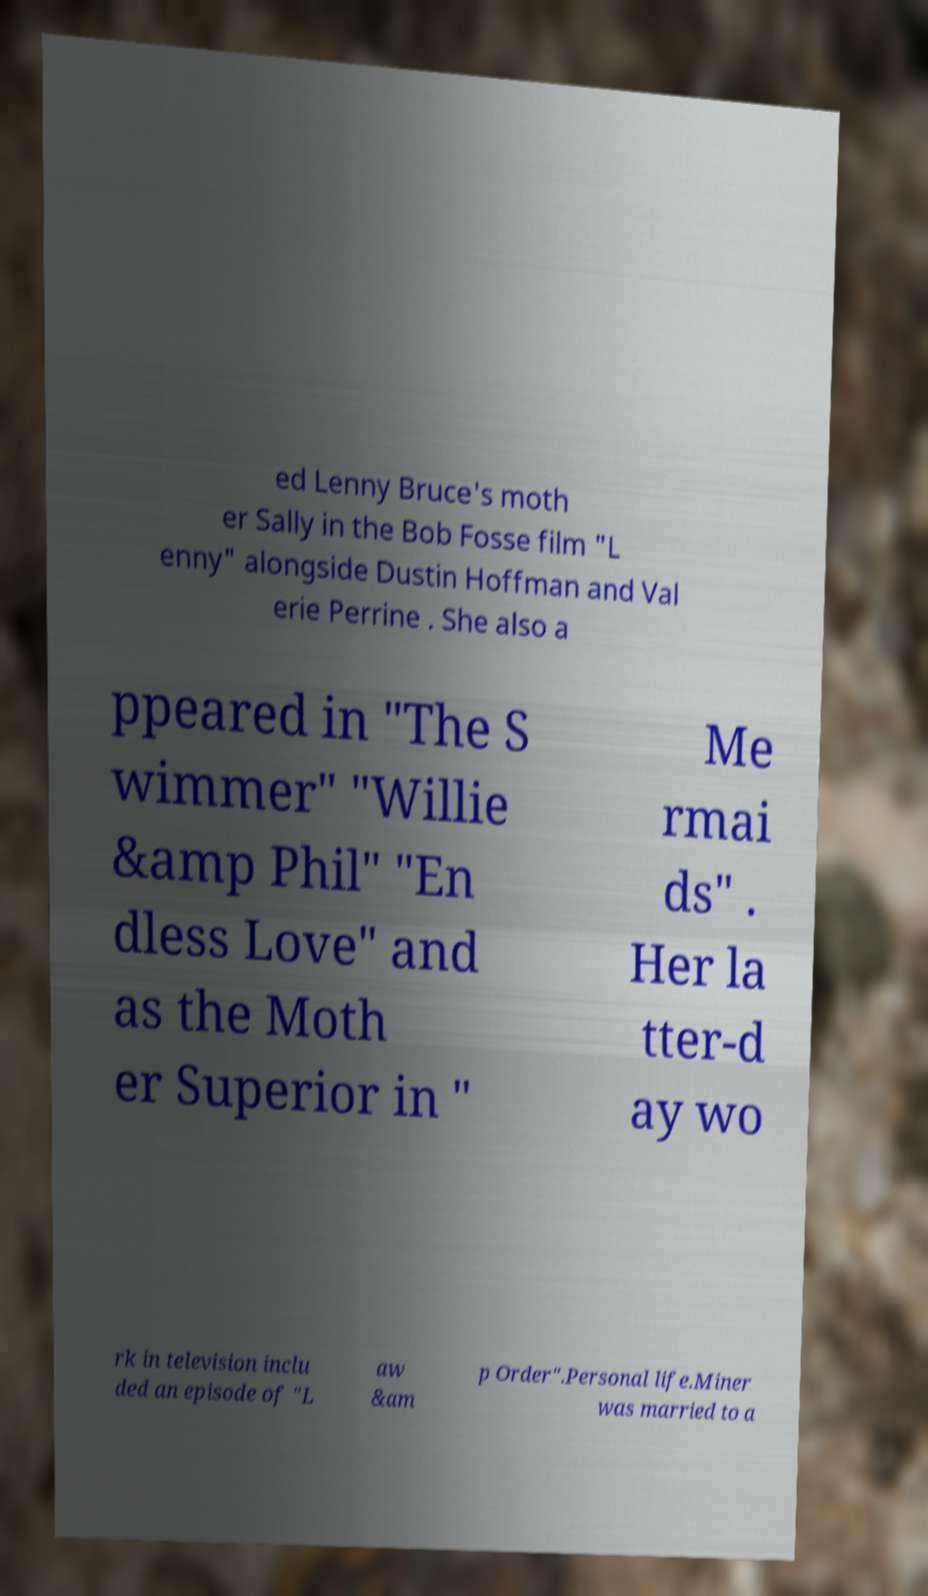Can you accurately transcribe the text from the provided image for me? ed Lenny Bruce's moth er Sally in the Bob Fosse film "L enny" alongside Dustin Hoffman and Val erie Perrine . She also a ppeared in "The S wimmer" "Willie &amp Phil" "En dless Love" and as the Moth er Superior in " Me rmai ds" . Her la tter-d ay wo rk in television inclu ded an episode of "L aw &am p Order".Personal life.Miner was married to a 